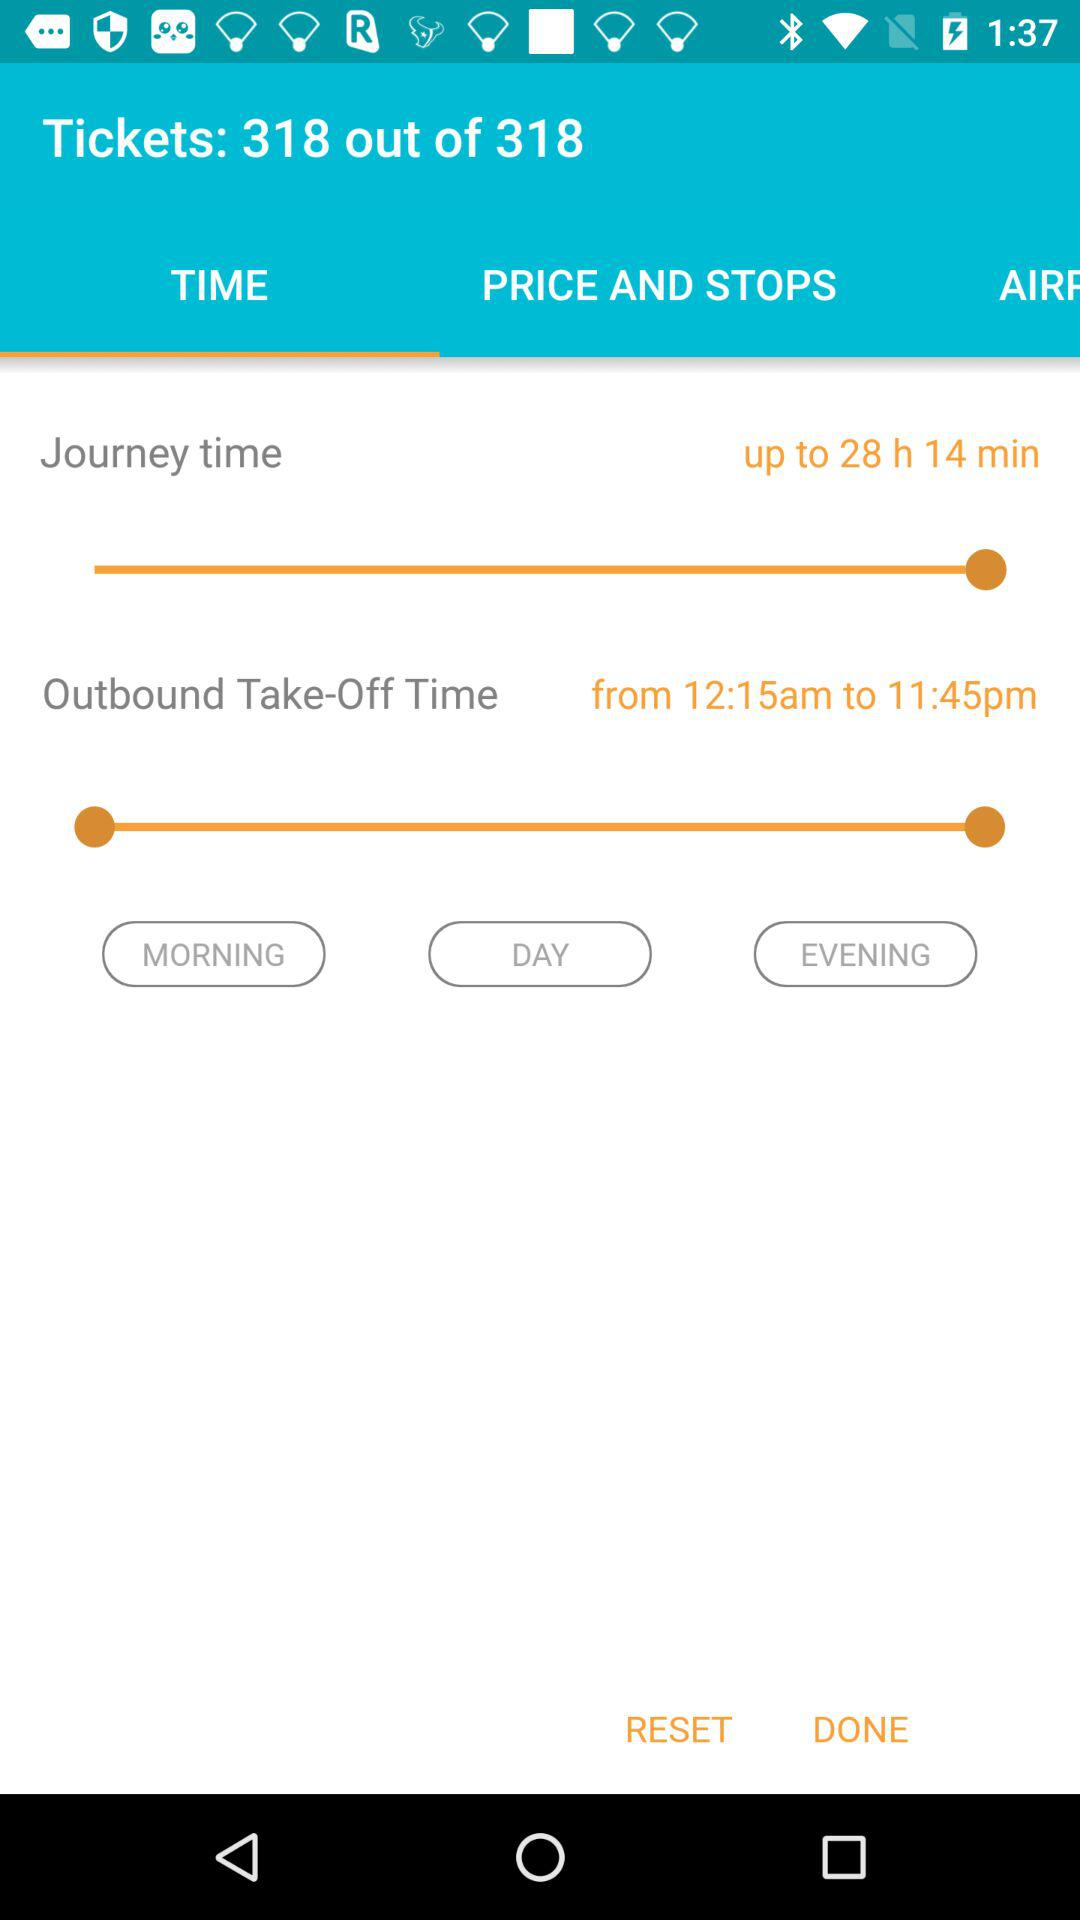What is the maximum departure time?
Answer the question using a single word or phrase. 11:45pm 